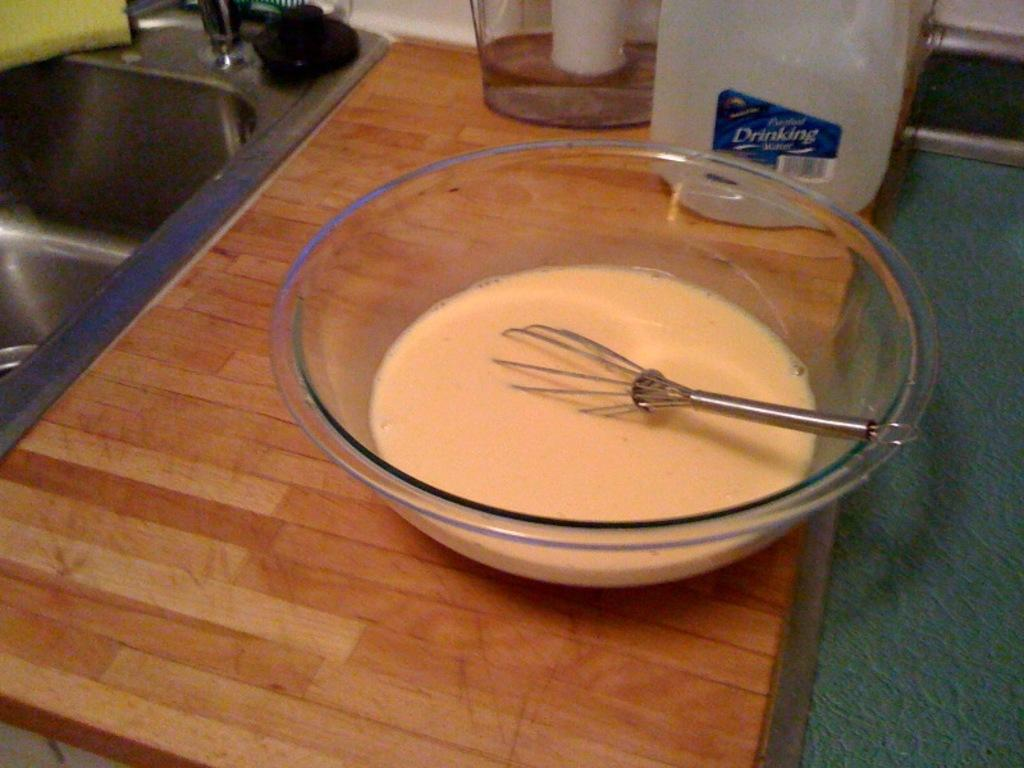What is on the table in the image? There is a bowl and a bottle on the table in the image. What is inside the bowl? The bowl contains liquid. What is being used to mix the liquid in the bowl? There is a whisk in the bowl. What other container is present on the table? There is a jar on the table. What can be seen on the left side of the image? There is a sink on the left side of the image. What color is the grape that is being used to shape the dough in the image? There is no grape or dough present in the image. What type of pain is the person in the image experiencing? There is no person or indication of pain in the image. 